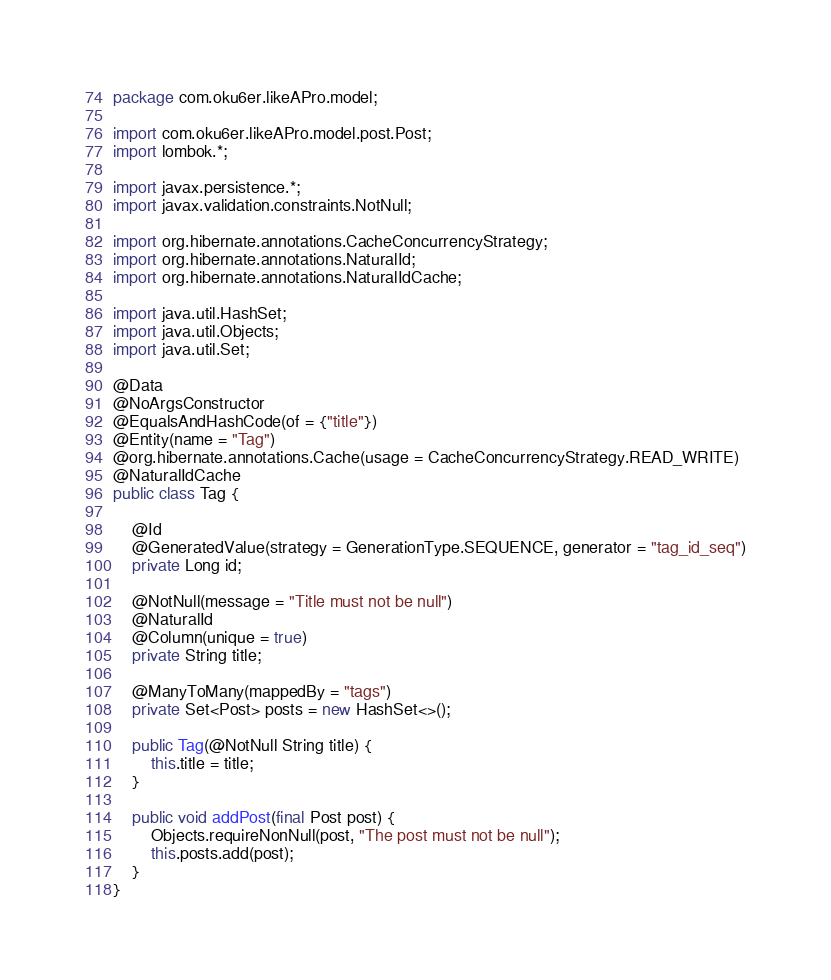<code> <loc_0><loc_0><loc_500><loc_500><_Java_>package com.oku6er.likeAPro.model;

import com.oku6er.likeAPro.model.post.Post;
import lombok.*;

import javax.persistence.*;
import javax.validation.constraints.NotNull;

import org.hibernate.annotations.CacheConcurrencyStrategy;
import org.hibernate.annotations.NaturalId;
import org.hibernate.annotations.NaturalIdCache;

import java.util.HashSet;
import java.util.Objects;
import java.util.Set;

@Data
@NoArgsConstructor
@EqualsAndHashCode(of = {"title"})
@Entity(name = "Tag")
@org.hibernate.annotations.Cache(usage = CacheConcurrencyStrategy.READ_WRITE)
@NaturalIdCache
public class Tag {

    @Id
    @GeneratedValue(strategy = GenerationType.SEQUENCE, generator = "tag_id_seq")
    private Long id;

    @NotNull(message = "Title must not be null")
    @NaturalId
    @Column(unique = true)
    private String title;

    @ManyToMany(mappedBy = "tags")
    private Set<Post> posts = new HashSet<>();

    public Tag(@NotNull String title) {
        this.title = title;
    }

    public void addPost(final Post post) {
        Objects.requireNonNull(post, "The post must not be null");
        this.posts.add(post);
    }
}
</code> 